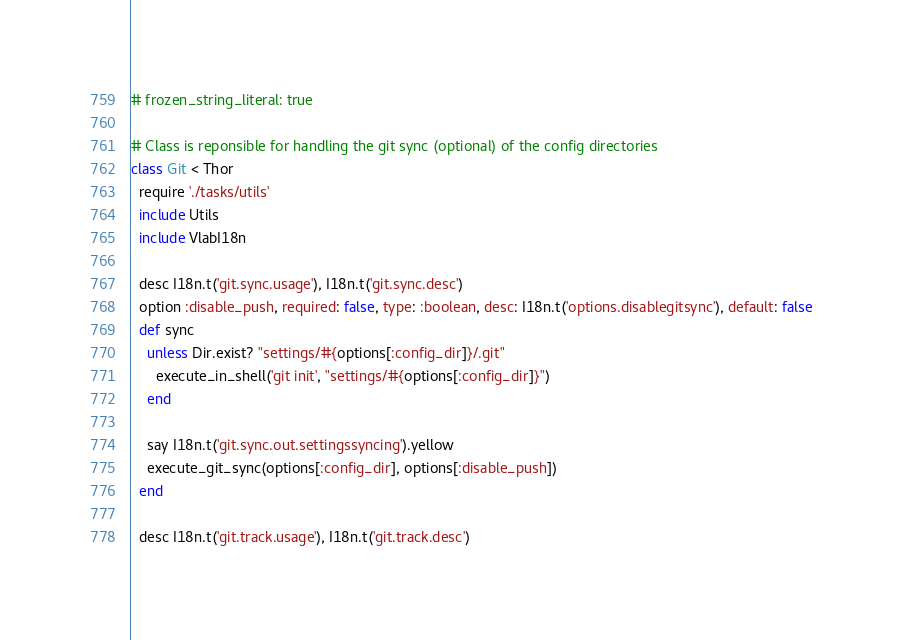<code> <loc_0><loc_0><loc_500><loc_500><_Ruby_># frozen_string_literal: true

# Class is reponsible for handling the git sync (optional) of the config directories
class Git < Thor
  require './tasks/utils'
  include Utils
  include VlabI18n

  desc I18n.t('git.sync.usage'), I18n.t('git.sync.desc')
  option :disable_push, required: false, type: :boolean, desc: I18n.t('options.disablegitsync'), default: false
  def sync
    unless Dir.exist? "settings/#{options[:config_dir]}/.git"
      execute_in_shell('git init', "settings/#{options[:config_dir]}")
    end

    say I18n.t('git.sync.out.settingssyncing').yellow
    execute_git_sync(options[:config_dir], options[:disable_push])
  end

  desc I18n.t('git.track.usage'), I18n.t('git.track.desc')</code> 